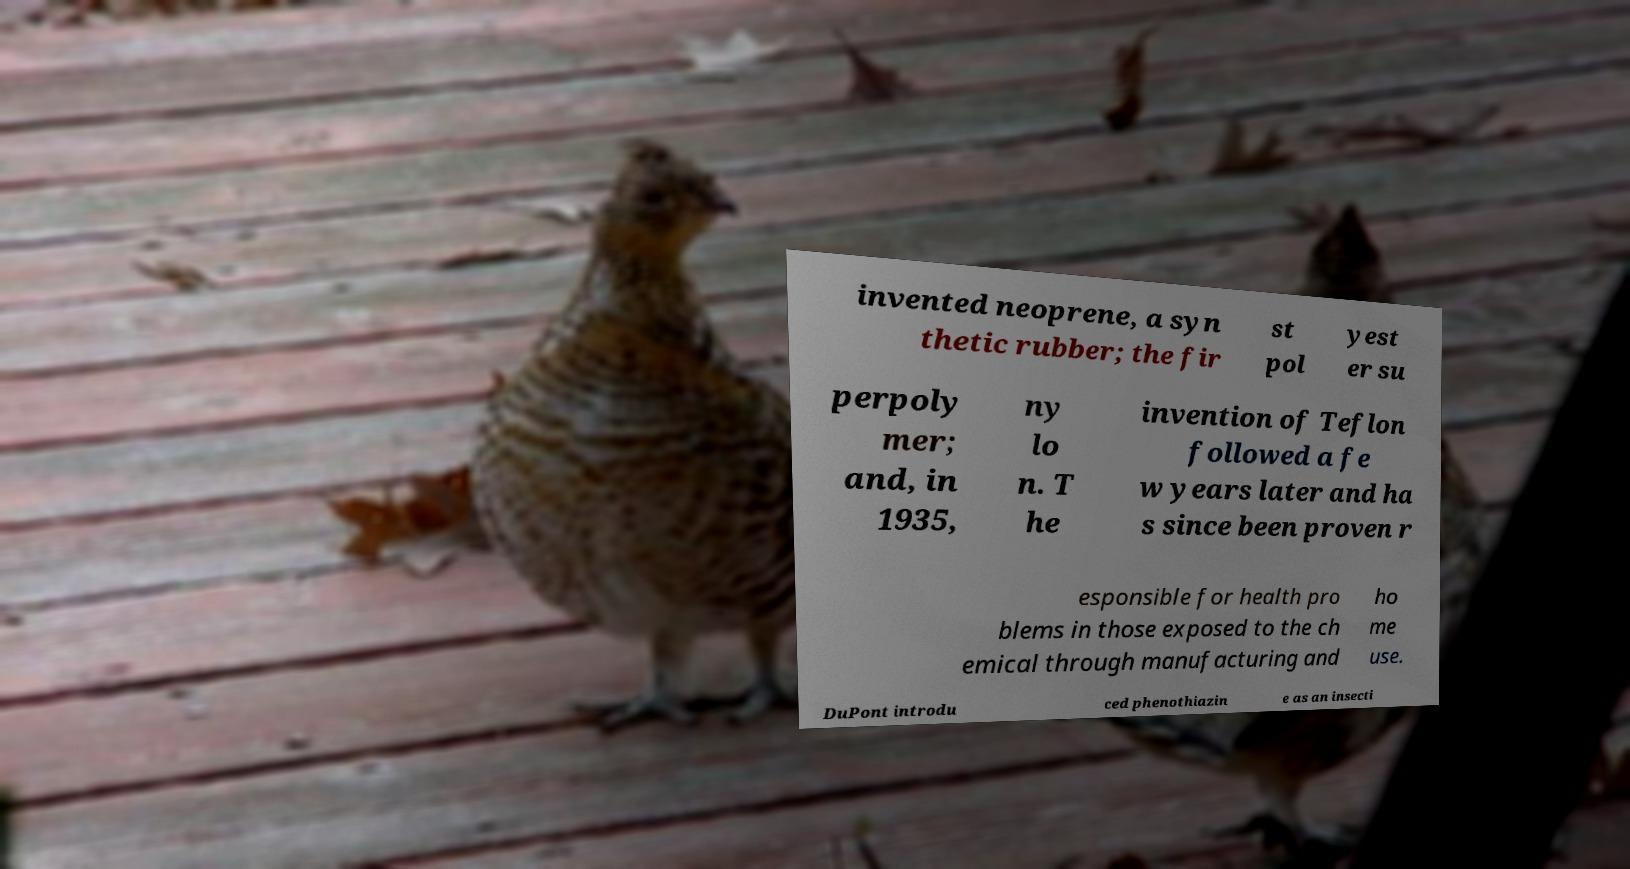Could you extract and type out the text from this image? invented neoprene, a syn thetic rubber; the fir st pol yest er su perpoly mer; and, in 1935, ny lo n. T he invention of Teflon followed a fe w years later and ha s since been proven r esponsible for health pro blems in those exposed to the ch emical through manufacturing and ho me use. DuPont introdu ced phenothiazin e as an insecti 